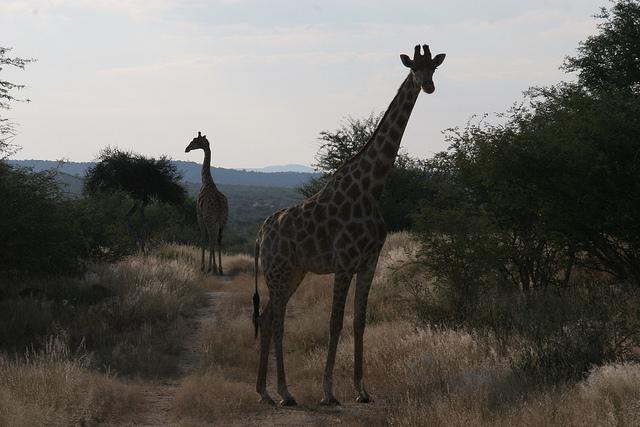Is it an adult or baby giraffe?
Short answer required. Adult. Are the giraffe being contained in their habitat?
Keep it brief. No. Is this photo copyrighted?
Be succinct. No. Is this giraffe being kept in a zoo?
Concise answer only. No. Where it the giraffe standing at?
Concise answer only. Grass. Is this giraffe in a zoo?
Be succinct. No. Are the giraffes friends?
Write a very short answer. Yes. Are the giraffe's in their natural habitat?
Short answer required. Yes. How many giraffes are there?
Quick response, please. 2. Are the giraffes facing the same direction?
Concise answer only. No. Are these animals in their natural habitat?
Keep it brief. Yes. 